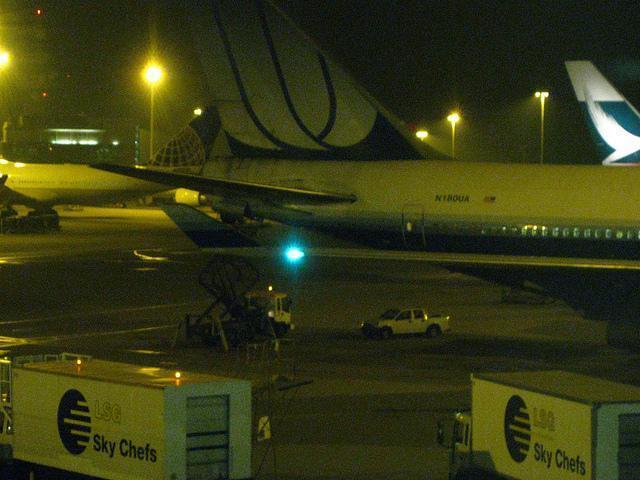How many airplanes are in the picture?
Give a very brief answer. 2. How many trucks are visible?
Give a very brief answer. 4. How many people are in the image?
Give a very brief answer. 0. 